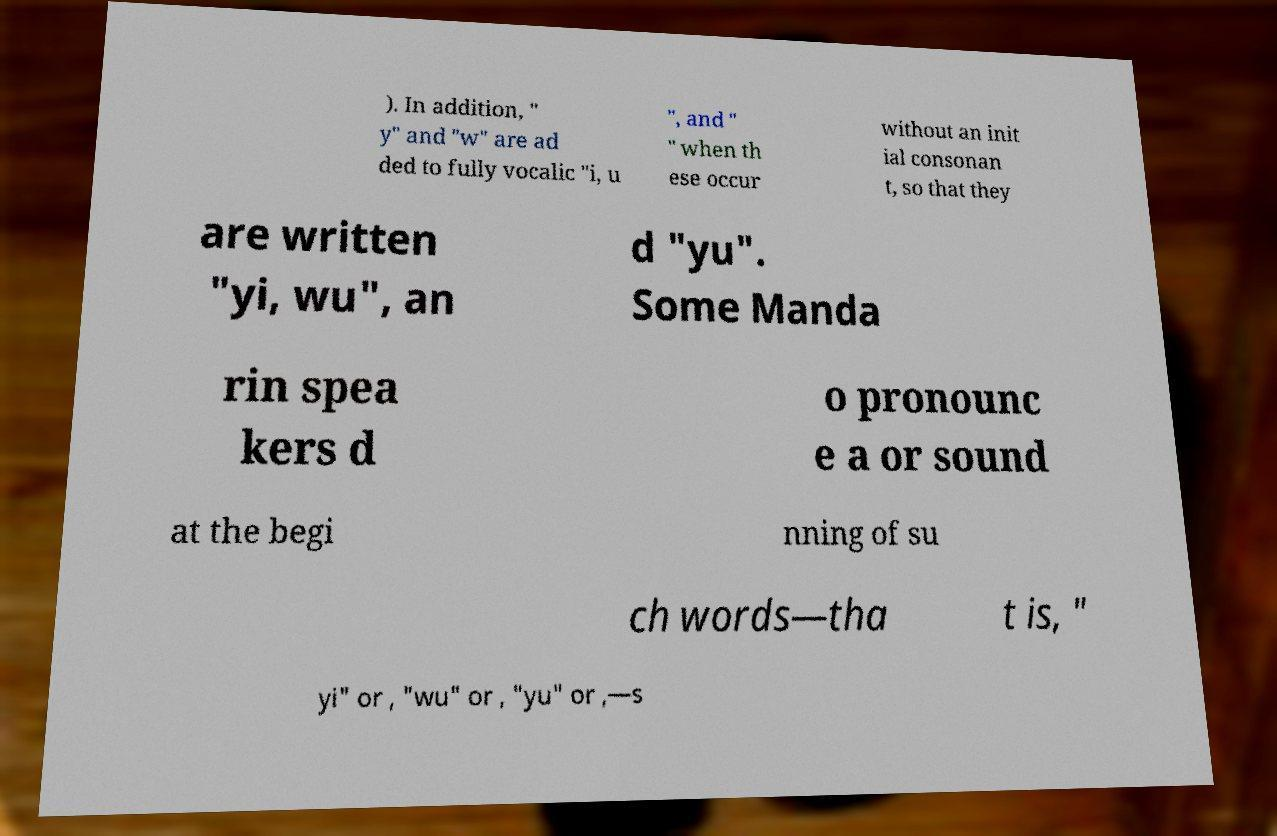Can you read and provide the text displayed in the image?This photo seems to have some interesting text. Can you extract and type it out for me? ). In addition, " y" and "w" are ad ded to fully vocalic "i, u ", and " " when th ese occur without an init ial consonan t, so that they are written "yi, wu", an d "yu". Some Manda rin spea kers d o pronounc e a or sound at the begi nning of su ch words—tha t is, " yi" or , "wu" or , "yu" or ,—s 